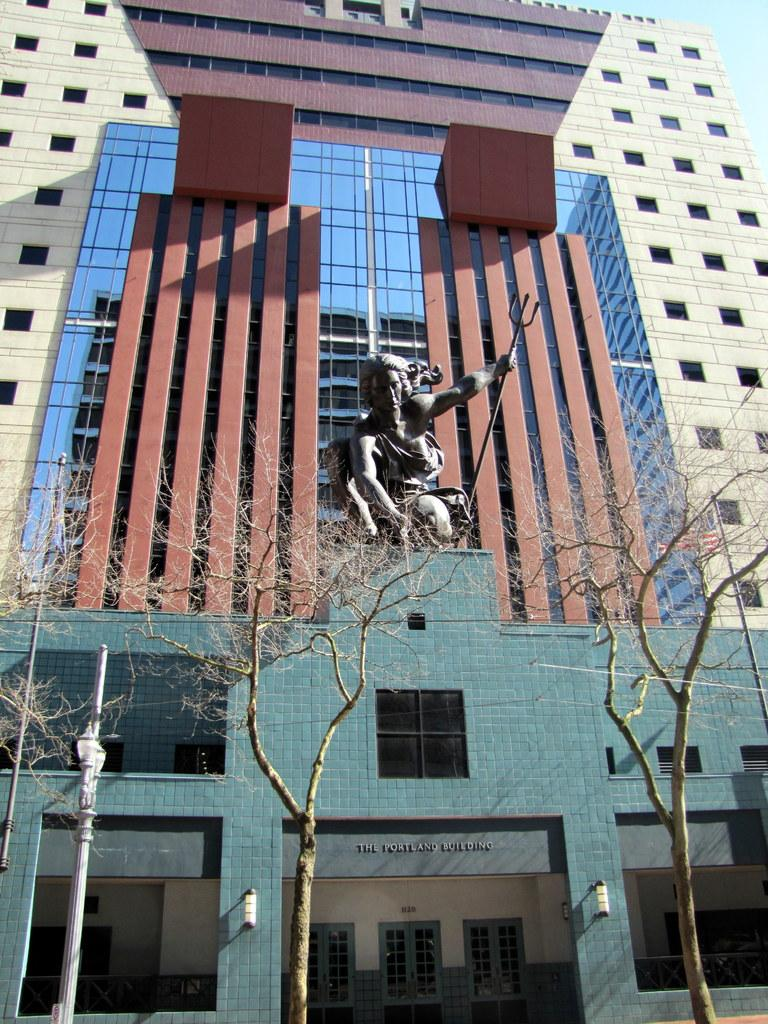What type of vegetation is present in the image? There are trees in the image. What type of structure can be seen in the image? There is a building in the image. What objects are present in the image that provide illumination? There are lights in the image. What type of vertical structures are present in the image? A: There are poles in the image. What type of artwork is present in the image? There is a sculpture of a person holding a trishul in the image. What part of the natural environment is visible in the image? The sky is visible in the image. What type of farm animals can be seen grazing in the image? There are no farm animals present in the image. What type of transport is available for the sculpture to move around in the image? The sculpture is a stationary object and does not require transport in the image. 